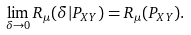<formula> <loc_0><loc_0><loc_500><loc_500>\lim _ { \delta \to 0 } R _ { \mu } ( \delta | P _ { X Y } ) = R _ { \mu } ( P _ { X Y } ) .</formula> 